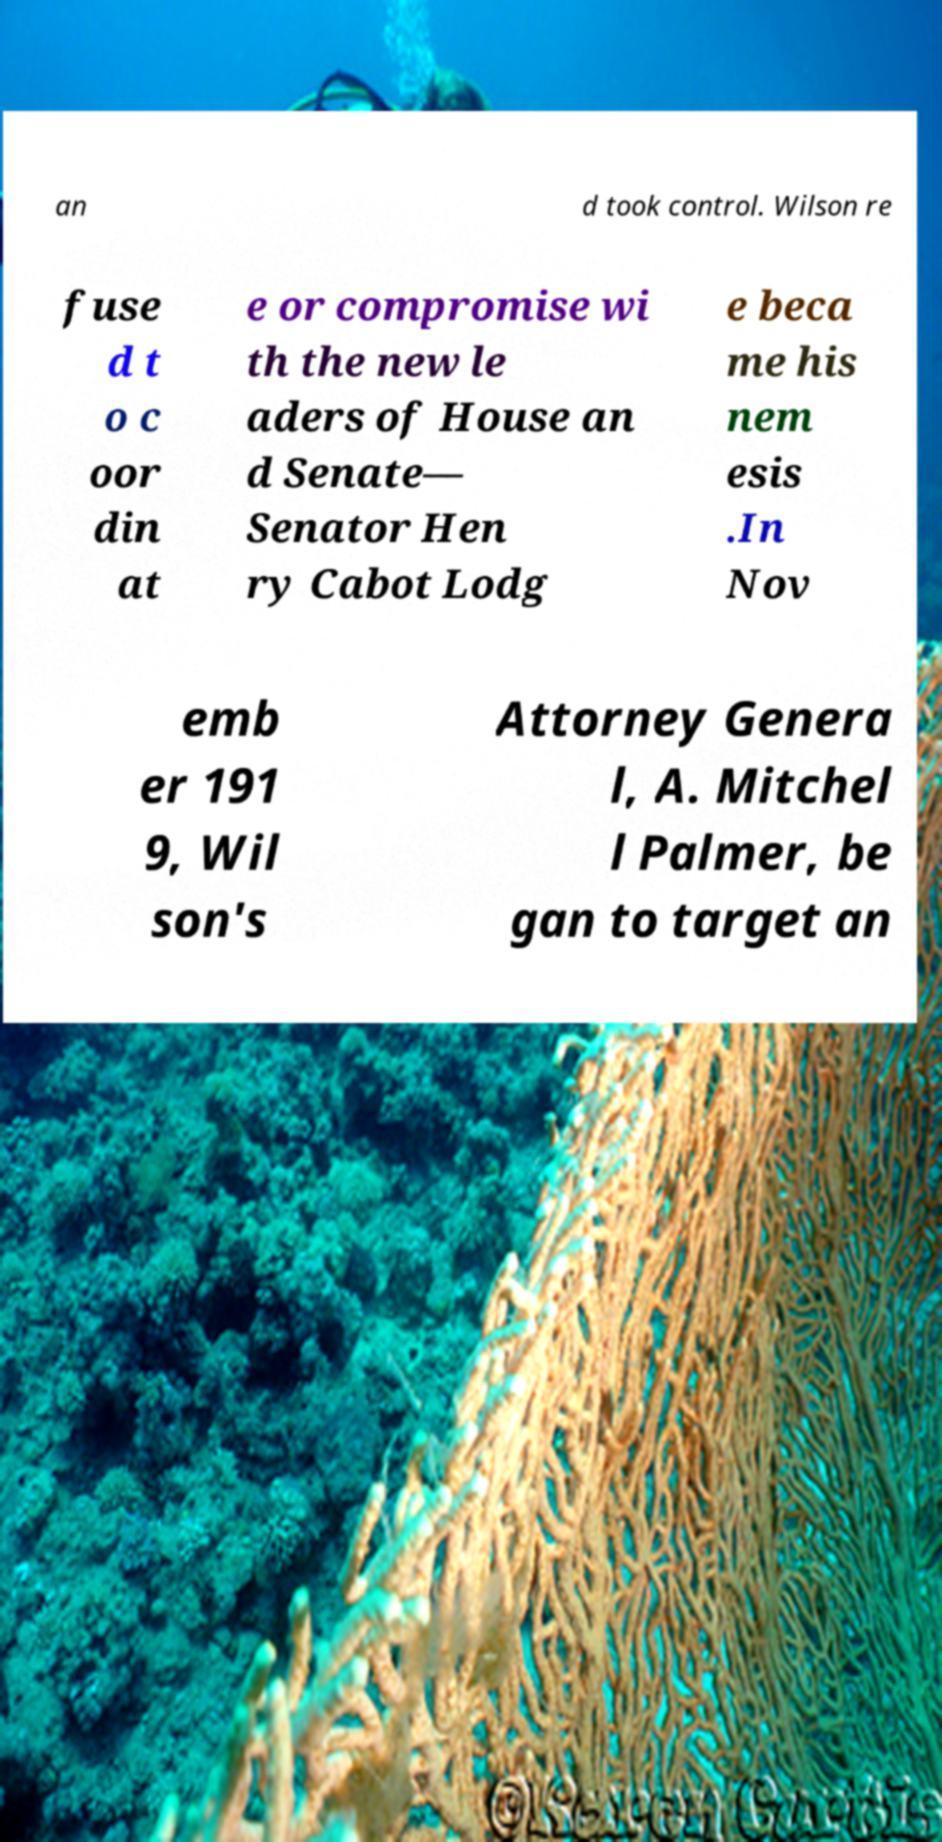For documentation purposes, I need the text within this image transcribed. Could you provide that? an d took control. Wilson re fuse d t o c oor din at e or compromise wi th the new le aders of House an d Senate— Senator Hen ry Cabot Lodg e beca me his nem esis .In Nov emb er 191 9, Wil son's Attorney Genera l, A. Mitchel l Palmer, be gan to target an 